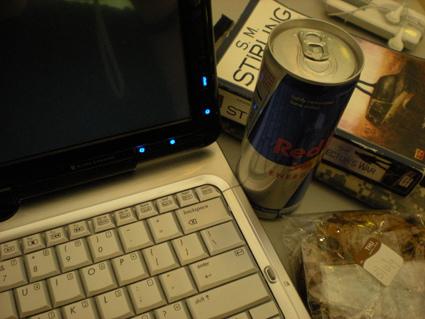What theme are the books?
Concise answer only. Fiction. What famous cartoon character is on the front of the book?
Answer briefly. None. Which portion of the keyboard is visible?
Concise answer only. Upper right. What color is the photo?
Be succinct. Gray. Is the screen on?
Concise answer only. No. Is this a color photo?
Answer briefly. Yes. Where is the tab key?
Write a very short answer. Left. Is the computer a Mac?
Write a very short answer. No. What drink is in the can?
Answer briefly. Red bull. Is the computer on?
Be succinct. Yes. 